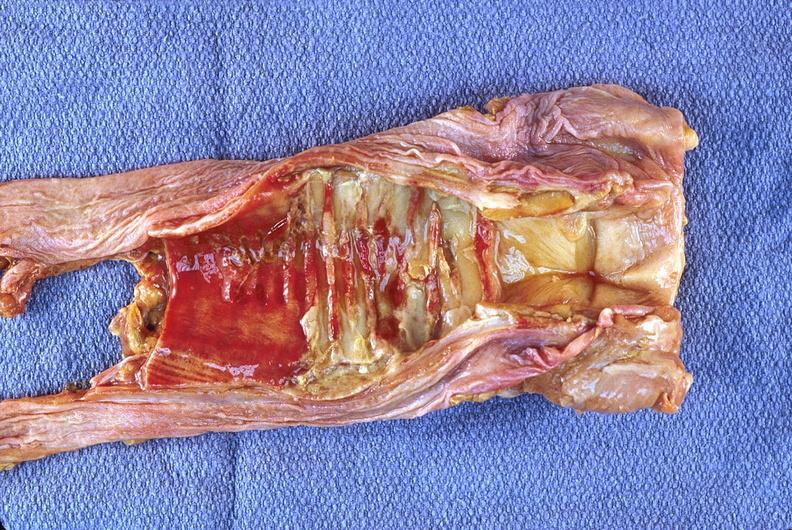s respiratory present?
Answer the question using a single word or phrase. Yes 